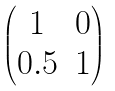Convert formula to latex. <formula><loc_0><loc_0><loc_500><loc_500>\begin{pmatrix} 1 & 0 \\ 0 . 5 & 1 \end{pmatrix}</formula> 